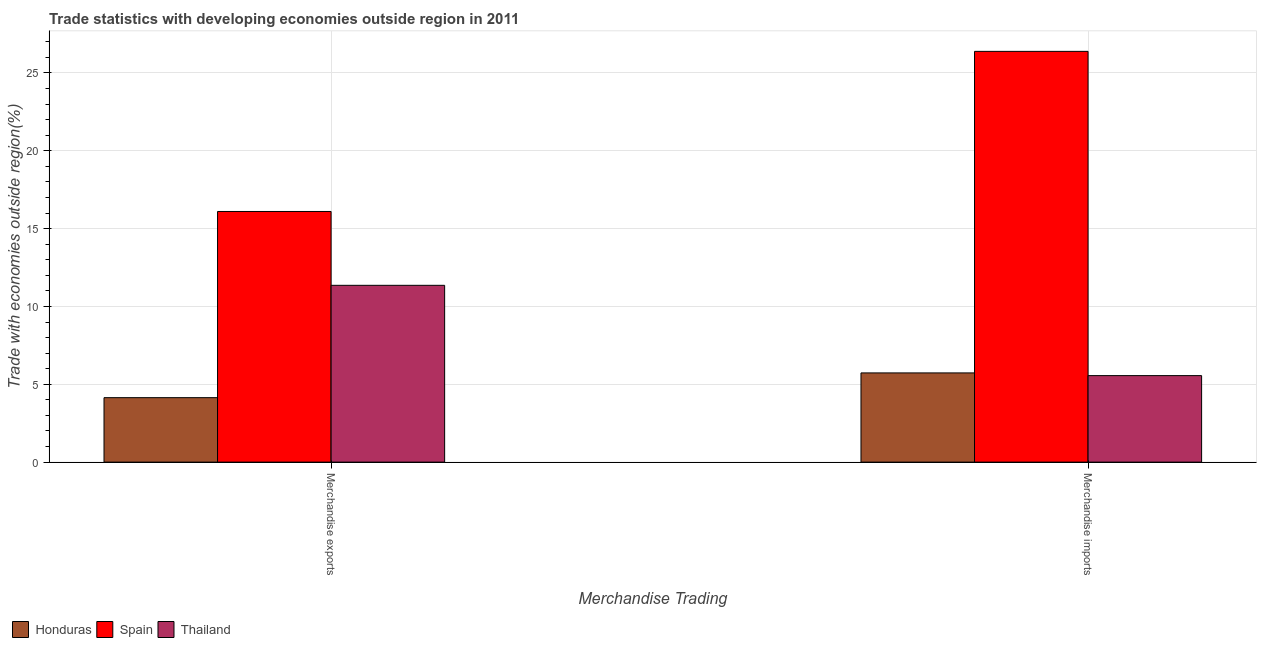Are the number of bars on each tick of the X-axis equal?
Ensure brevity in your answer.  Yes. How many bars are there on the 2nd tick from the right?
Keep it short and to the point. 3. What is the merchandise exports in Honduras?
Offer a very short reply. 4.14. Across all countries, what is the maximum merchandise imports?
Your answer should be very brief. 26.38. Across all countries, what is the minimum merchandise exports?
Your answer should be very brief. 4.14. In which country was the merchandise exports minimum?
Make the answer very short. Honduras. What is the total merchandise exports in the graph?
Offer a very short reply. 31.6. What is the difference between the merchandise imports in Honduras and that in Thailand?
Your answer should be compact. 0.17. What is the difference between the merchandise imports in Honduras and the merchandise exports in Spain?
Give a very brief answer. -10.37. What is the average merchandise exports per country?
Offer a very short reply. 10.53. What is the difference between the merchandise imports and merchandise exports in Thailand?
Offer a terse response. -5.8. In how many countries, is the merchandise exports greater than 14 %?
Provide a short and direct response. 1. What is the ratio of the merchandise exports in Spain to that in Honduras?
Your response must be concise. 3.89. Is the merchandise exports in Honduras less than that in Thailand?
Your response must be concise. Yes. In how many countries, is the merchandise imports greater than the average merchandise imports taken over all countries?
Give a very brief answer. 1. What does the 2nd bar from the right in Merchandise imports represents?
Provide a succinct answer. Spain. What is the difference between two consecutive major ticks on the Y-axis?
Offer a terse response. 5. Where does the legend appear in the graph?
Offer a terse response. Bottom left. How are the legend labels stacked?
Keep it short and to the point. Horizontal. What is the title of the graph?
Offer a terse response. Trade statistics with developing economies outside region in 2011. What is the label or title of the X-axis?
Give a very brief answer. Merchandise Trading. What is the label or title of the Y-axis?
Provide a succinct answer. Trade with economies outside region(%). What is the Trade with economies outside region(%) of Honduras in Merchandise exports?
Offer a terse response. 4.14. What is the Trade with economies outside region(%) in Spain in Merchandise exports?
Keep it short and to the point. 16.1. What is the Trade with economies outside region(%) in Thailand in Merchandise exports?
Your response must be concise. 11.36. What is the Trade with economies outside region(%) in Honduras in Merchandise imports?
Make the answer very short. 5.73. What is the Trade with economies outside region(%) of Spain in Merchandise imports?
Provide a short and direct response. 26.38. What is the Trade with economies outside region(%) of Thailand in Merchandise imports?
Provide a short and direct response. 5.56. Across all Merchandise Trading, what is the maximum Trade with economies outside region(%) of Honduras?
Your response must be concise. 5.73. Across all Merchandise Trading, what is the maximum Trade with economies outside region(%) in Spain?
Your answer should be compact. 26.38. Across all Merchandise Trading, what is the maximum Trade with economies outside region(%) in Thailand?
Ensure brevity in your answer.  11.36. Across all Merchandise Trading, what is the minimum Trade with economies outside region(%) of Honduras?
Give a very brief answer. 4.14. Across all Merchandise Trading, what is the minimum Trade with economies outside region(%) in Spain?
Make the answer very short. 16.1. Across all Merchandise Trading, what is the minimum Trade with economies outside region(%) in Thailand?
Offer a very short reply. 5.56. What is the total Trade with economies outside region(%) in Honduras in the graph?
Offer a terse response. 9.87. What is the total Trade with economies outside region(%) in Spain in the graph?
Your answer should be compact. 42.48. What is the total Trade with economies outside region(%) of Thailand in the graph?
Give a very brief answer. 16.91. What is the difference between the Trade with economies outside region(%) in Honduras in Merchandise exports and that in Merchandise imports?
Your answer should be very brief. -1.59. What is the difference between the Trade with economies outside region(%) of Spain in Merchandise exports and that in Merchandise imports?
Ensure brevity in your answer.  -10.28. What is the difference between the Trade with economies outside region(%) in Thailand in Merchandise exports and that in Merchandise imports?
Your answer should be very brief. 5.8. What is the difference between the Trade with economies outside region(%) of Honduras in Merchandise exports and the Trade with economies outside region(%) of Spain in Merchandise imports?
Ensure brevity in your answer.  -22.24. What is the difference between the Trade with economies outside region(%) in Honduras in Merchandise exports and the Trade with economies outside region(%) in Thailand in Merchandise imports?
Your answer should be compact. -1.42. What is the difference between the Trade with economies outside region(%) in Spain in Merchandise exports and the Trade with economies outside region(%) in Thailand in Merchandise imports?
Your response must be concise. 10.54. What is the average Trade with economies outside region(%) in Honduras per Merchandise Trading?
Your answer should be very brief. 4.94. What is the average Trade with economies outside region(%) in Spain per Merchandise Trading?
Give a very brief answer. 21.24. What is the average Trade with economies outside region(%) of Thailand per Merchandise Trading?
Give a very brief answer. 8.46. What is the difference between the Trade with economies outside region(%) of Honduras and Trade with economies outside region(%) of Spain in Merchandise exports?
Your answer should be very brief. -11.96. What is the difference between the Trade with economies outside region(%) of Honduras and Trade with economies outside region(%) of Thailand in Merchandise exports?
Give a very brief answer. -7.22. What is the difference between the Trade with economies outside region(%) in Spain and Trade with economies outside region(%) in Thailand in Merchandise exports?
Make the answer very short. 4.74. What is the difference between the Trade with economies outside region(%) in Honduras and Trade with economies outside region(%) in Spain in Merchandise imports?
Offer a very short reply. -20.65. What is the difference between the Trade with economies outside region(%) in Honduras and Trade with economies outside region(%) in Thailand in Merchandise imports?
Your answer should be very brief. 0.17. What is the difference between the Trade with economies outside region(%) in Spain and Trade with economies outside region(%) in Thailand in Merchandise imports?
Your answer should be compact. 20.83. What is the ratio of the Trade with economies outside region(%) in Honduras in Merchandise exports to that in Merchandise imports?
Make the answer very short. 0.72. What is the ratio of the Trade with economies outside region(%) of Spain in Merchandise exports to that in Merchandise imports?
Keep it short and to the point. 0.61. What is the ratio of the Trade with economies outside region(%) in Thailand in Merchandise exports to that in Merchandise imports?
Keep it short and to the point. 2.04. What is the difference between the highest and the second highest Trade with economies outside region(%) of Honduras?
Offer a very short reply. 1.59. What is the difference between the highest and the second highest Trade with economies outside region(%) of Spain?
Your answer should be very brief. 10.28. What is the difference between the highest and the second highest Trade with economies outside region(%) in Thailand?
Your response must be concise. 5.8. What is the difference between the highest and the lowest Trade with economies outside region(%) of Honduras?
Provide a short and direct response. 1.59. What is the difference between the highest and the lowest Trade with economies outside region(%) of Spain?
Your answer should be very brief. 10.28. What is the difference between the highest and the lowest Trade with economies outside region(%) of Thailand?
Your response must be concise. 5.8. 